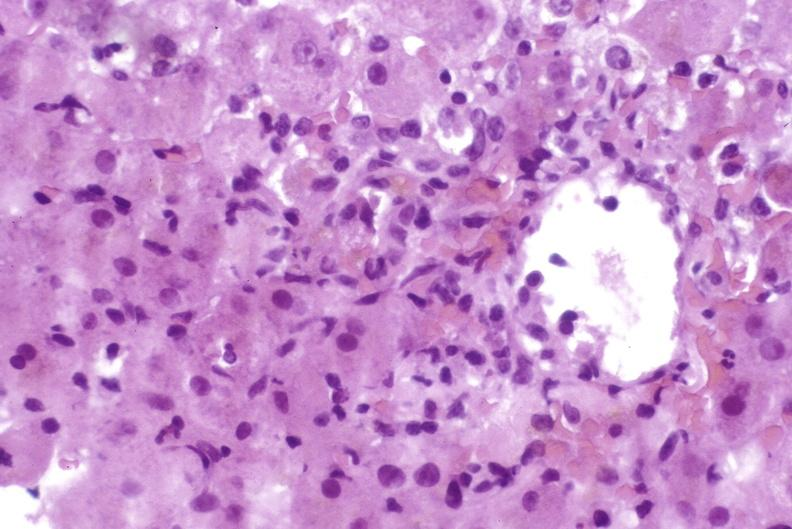what is present?
Answer the question using a single word or phrase. Liver 